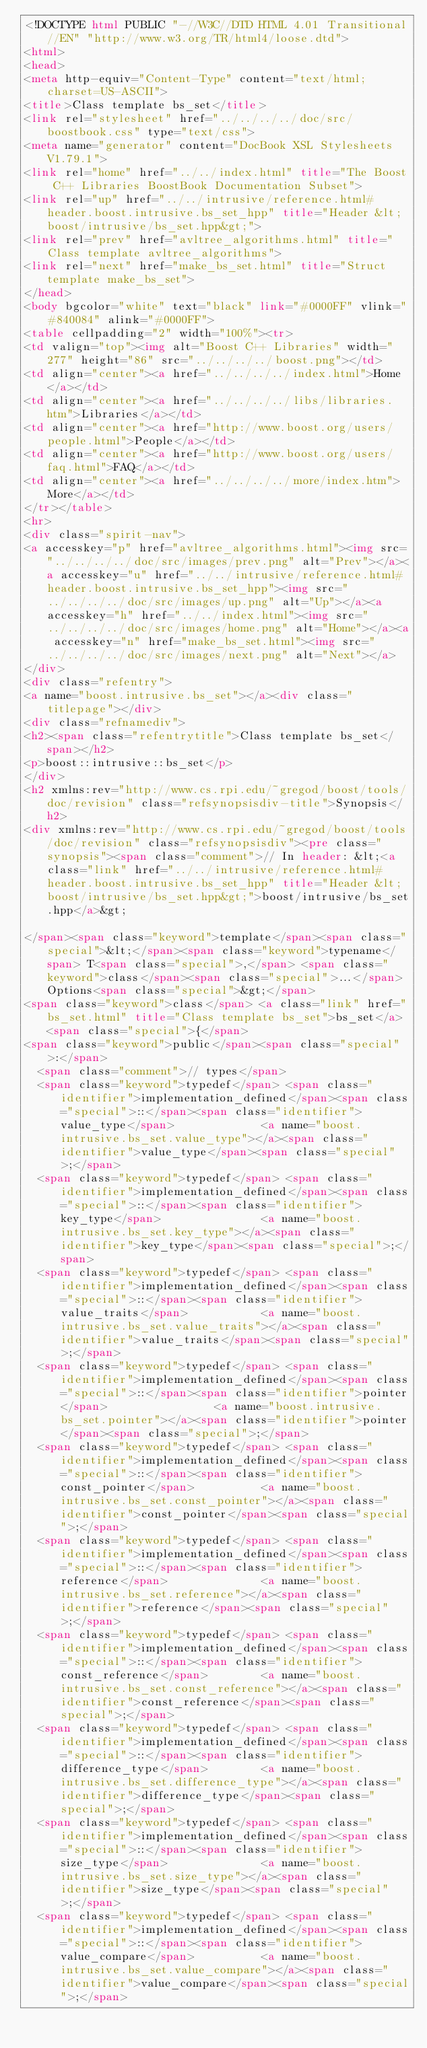Convert code to text. <code><loc_0><loc_0><loc_500><loc_500><_HTML_><!DOCTYPE html PUBLIC "-//W3C//DTD HTML 4.01 Transitional//EN" "http://www.w3.org/TR/html4/loose.dtd">
<html>
<head>
<meta http-equiv="Content-Type" content="text/html; charset=US-ASCII">
<title>Class template bs_set</title>
<link rel="stylesheet" href="../../../../doc/src/boostbook.css" type="text/css">
<meta name="generator" content="DocBook XSL Stylesheets V1.79.1">
<link rel="home" href="../../index.html" title="The Boost C++ Libraries BoostBook Documentation Subset">
<link rel="up" href="../../intrusive/reference.html#header.boost.intrusive.bs_set_hpp" title="Header &lt;boost/intrusive/bs_set.hpp&gt;">
<link rel="prev" href="avltree_algorithms.html" title="Class template avltree_algorithms">
<link rel="next" href="make_bs_set.html" title="Struct template make_bs_set">
</head>
<body bgcolor="white" text="black" link="#0000FF" vlink="#840084" alink="#0000FF">
<table cellpadding="2" width="100%"><tr>
<td valign="top"><img alt="Boost C++ Libraries" width="277" height="86" src="../../../../boost.png"></td>
<td align="center"><a href="../../../../index.html">Home</a></td>
<td align="center"><a href="../../../../libs/libraries.htm">Libraries</a></td>
<td align="center"><a href="http://www.boost.org/users/people.html">People</a></td>
<td align="center"><a href="http://www.boost.org/users/faq.html">FAQ</a></td>
<td align="center"><a href="../../../../more/index.htm">More</a></td>
</tr></table>
<hr>
<div class="spirit-nav">
<a accesskey="p" href="avltree_algorithms.html"><img src="../../../../doc/src/images/prev.png" alt="Prev"></a><a accesskey="u" href="../../intrusive/reference.html#header.boost.intrusive.bs_set_hpp"><img src="../../../../doc/src/images/up.png" alt="Up"></a><a accesskey="h" href="../../index.html"><img src="../../../../doc/src/images/home.png" alt="Home"></a><a accesskey="n" href="make_bs_set.html"><img src="../../../../doc/src/images/next.png" alt="Next"></a>
</div>
<div class="refentry">
<a name="boost.intrusive.bs_set"></a><div class="titlepage"></div>
<div class="refnamediv">
<h2><span class="refentrytitle">Class template bs_set</span></h2>
<p>boost::intrusive::bs_set</p>
</div>
<h2 xmlns:rev="http://www.cs.rpi.edu/~gregod/boost/tools/doc/revision" class="refsynopsisdiv-title">Synopsis</h2>
<div xmlns:rev="http://www.cs.rpi.edu/~gregod/boost/tools/doc/revision" class="refsynopsisdiv"><pre class="synopsis"><span class="comment">// In header: &lt;<a class="link" href="../../intrusive/reference.html#header.boost.intrusive.bs_set_hpp" title="Header &lt;boost/intrusive/bs_set.hpp&gt;">boost/intrusive/bs_set.hpp</a>&gt;

</span><span class="keyword">template</span><span class="special">&lt;</span><span class="keyword">typename</span> T<span class="special">,</span> <span class="keyword">class</span><span class="special">...</span> Options<span class="special">&gt;</span> 
<span class="keyword">class</span> <a class="link" href="bs_set.html" title="Class template bs_set">bs_set</a> <span class="special">{</span>
<span class="keyword">public</span><span class="special">:</span>
  <span class="comment">// types</span>
  <span class="keyword">typedef</span> <span class="identifier">implementation_defined</span><span class="special">::</span><span class="identifier">value_type</span>             <a name="boost.intrusive.bs_set.value_type"></a><span class="identifier">value_type</span><span class="special">;</span>            
  <span class="keyword">typedef</span> <span class="identifier">implementation_defined</span><span class="special">::</span><span class="identifier">key_type</span>               <a name="boost.intrusive.bs_set.key_type"></a><span class="identifier">key_type</span><span class="special">;</span>              
  <span class="keyword">typedef</span> <span class="identifier">implementation_defined</span><span class="special">::</span><span class="identifier">value_traits</span>           <a name="boost.intrusive.bs_set.value_traits"></a><span class="identifier">value_traits</span><span class="special">;</span>          
  <span class="keyword">typedef</span> <span class="identifier">implementation_defined</span><span class="special">::</span><span class="identifier">pointer</span>                <a name="boost.intrusive.bs_set.pointer"></a><span class="identifier">pointer</span><span class="special">;</span>               
  <span class="keyword">typedef</span> <span class="identifier">implementation_defined</span><span class="special">::</span><span class="identifier">const_pointer</span>          <a name="boost.intrusive.bs_set.const_pointer"></a><span class="identifier">const_pointer</span><span class="special">;</span>         
  <span class="keyword">typedef</span> <span class="identifier">implementation_defined</span><span class="special">::</span><span class="identifier">reference</span>              <a name="boost.intrusive.bs_set.reference"></a><span class="identifier">reference</span><span class="special">;</span>             
  <span class="keyword">typedef</span> <span class="identifier">implementation_defined</span><span class="special">::</span><span class="identifier">const_reference</span>        <a name="boost.intrusive.bs_set.const_reference"></a><span class="identifier">const_reference</span><span class="special">;</span>       
  <span class="keyword">typedef</span> <span class="identifier">implementation_defined</span><span class="special">::</span><span class="identifier">difference_type</span>        <a name="boost.intrusive.bs_set.difference_type"></a><span class="identifier">difference_type</span><span class="special">;</span>       
  <span class="keyword">typedef</span> <span class="identifier">implementation_defined</span><span class="special">::</span><span class="identifier">size_type</span>              <a name="boost.intrusive.bs_set.size_type"></a><span class="identifier">size_type</span><span class="special">;</span>             
  <span class="keyword">typedef</span> <span class="identifier">implementation_defined</span><span class="special">::</span><span class="identifier">value_compare</span>          <a name="boost.intrusive.bs_set.value_compare"></a><span class="identifier">value_compare</span><span class="special">;</span>         </code> 